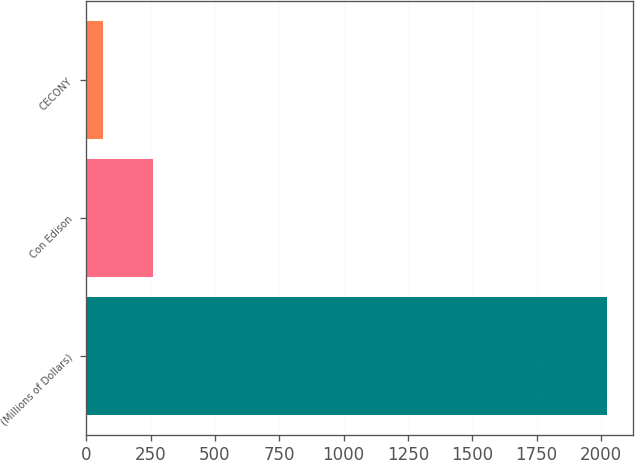<chart> <loc_0><loc_0><loc_500><loc_500><bar_chart><fcel>(Millions of Dollars)<fcel>Con Edison<fcel>CECONY<nl><fcel>2022<fcel>259.8<fcel>64<nl></chart> 